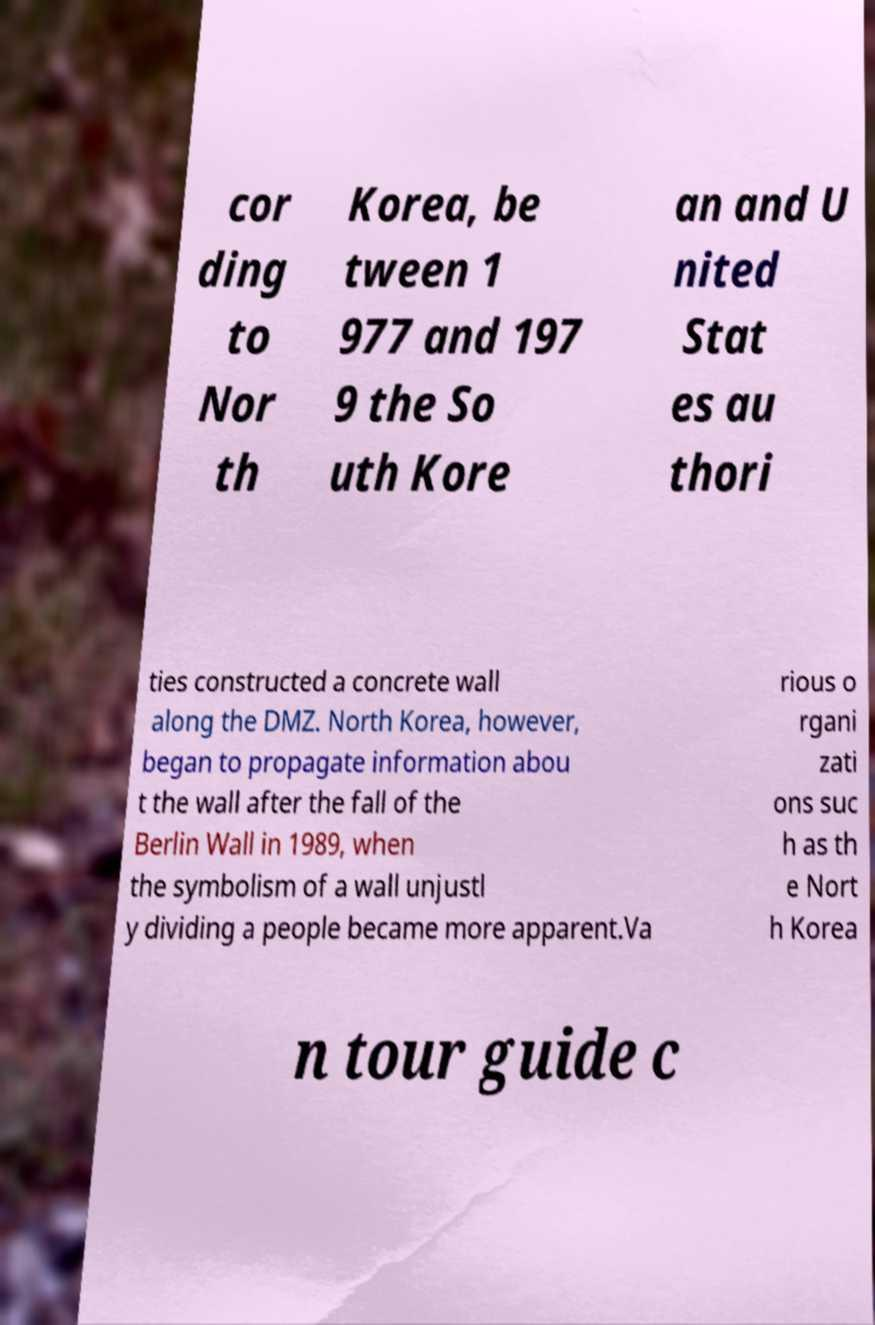Please read and relay the text visible in this image. What does it say? cor ding to Nor th Korea, be tween 1 977 and 197 9 the So uth Kore an and U nited Stat es au thori ties constructed a concrete wall along the DMZ. North Korea, however, began to propagate information abou t the wall after the fall of the Berlin Wall in 1989, when the symbolism of a wall unjustl y dividing a people became more apparent.Va rious o rgani zati ons suc h as th e Nort h Korea n tour guide c 